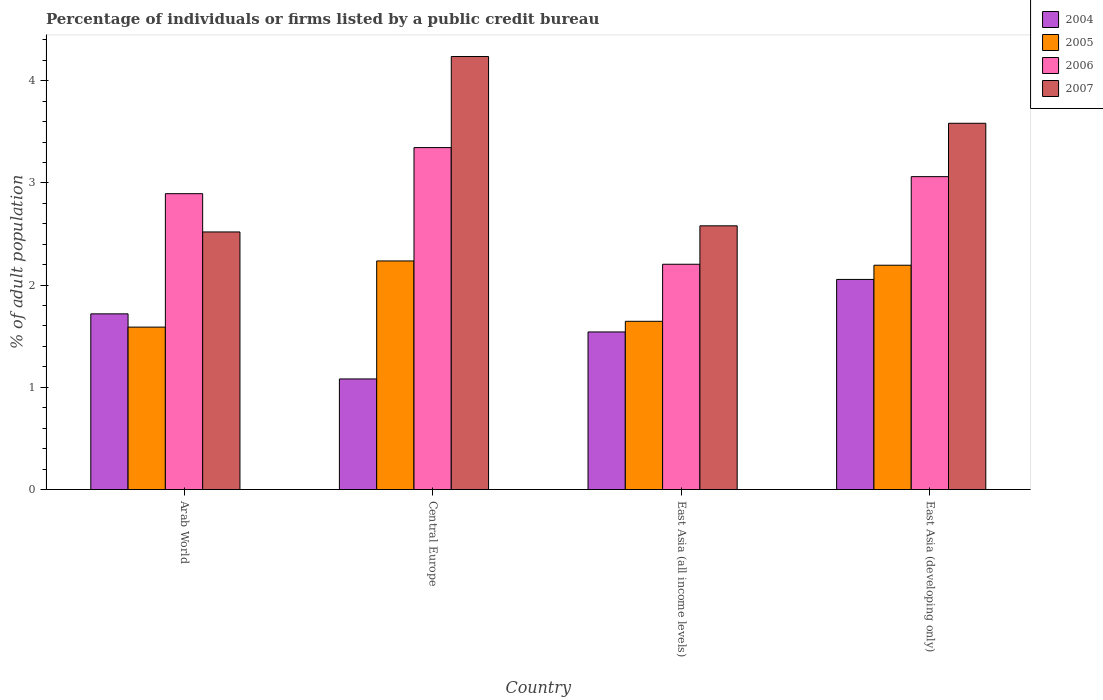How many different coloured bars are there?
Give a very brief answer. 4. Are the number of bars per tick equal to the number of legend labels?
Offer a very short reply. Yes. Are the number of bars on each tick of the X-axis equal?
Your answer should be very brief. Yes. What is the label of the 1st group of bars from the left?
Offer a very short reply. Arab World. In how many cases, is the number of bars for a given country not equal to the number of legend labels?
Make the answer very short. 0. What is the percentage of population listed by a public credit bureau in 2007 in East Asia (developing only)?
Ensure brevity in your answer.  3.58. Across all countries, what is the maximum percentage of population listed by a public credit bureau in 2004?
Your answer should be compact. 2.06. Across all countries, what is the minimum percentage of population listed by a public credit bureau in 2006?
Give a very brief answer. 2.2. In which country was the percentage of population listed by a public credit bureau in 2006 maximum?
Offer a very short reply. Central Europe. In which country was the percentage of population listed by a public credit bureau in 2005 minimum?
Offer a terse response. Arab World. What is the total percentage of population listed by a public credit bureau in 2004 in the graph?
Provide a succinct answer. 6.4. What is the difference between the percentage of population listed by a public credit bureau in 2007 in Arab World and that in East Asia (developing only)?
Your response must be concise. -1.06. What is the difference between the percentage of population listed by a public credit bureau in 2004 in East Asia (developing only) and the percentage of population listed by a public credit bureau in 2006 in Central Europe?
Make the answer very short. -1.29. What is the average percentage of population listed by a public credit bureau in 2006 per country?
Keep it short and to the point. 2.88. What is the difference between the percentage of population listed by a public credit bureau of/in 2006 and percentage of population listed by a public credit bureau of/in 2004 in East Asia (developing only)?
Make the answer very short. 1.01. In how many countries, is the percentage of population listed by a public credit bureau in 2004 greater than 3.6 %?
Your answer should be very brief. 0. What is the ratio of the percentage of population listed by a public credit bureau in 2004 in Central Europe to that in East Asia (all income levels)?
Keep it short and to the point. 0.7. Is the difference between the percentage of population listed by a public credit bureau in 2006 in Central Europe and East Asia (all income levels) greater than the difference between the percentage of population listed by a public credit bureau in 2004 in Central Europe and East Asia (all income levels)?
Keep it short and to the point. Yes. What is the difference between the highest and the second highest percentage of population listed by a public credit bureau in 2004?
Your answer should be very brief. -0.34. What is the difference between the highest and the lowest percentage of population listed by a public credit bureau in 2005?
Offer a terse response. 0.65. In how many countries, is the percentage of population listed by a public credit bureau in 2004 greater than the average percentage of population listed by a public credit bureau in 2004 taken over all countries?
Provide a short and direct response. 2. Is the sum of the percentage of population listed by a public credit bureau in 2005 in Arab World and East Asia (developing only) greater than the maximum percentage of population listed by a public credit bureau in 2007 across all countries?
Keep it short and to the point. No. Is it the case that in every country, the sum of the percentage of population listed by a public credit bureau in 2004 and percentage of population listed by a public credit bureau in 2005 is greater than the sum of percentage of population listed by a public credit bureau in 2007 and percentage of population listed by a public credit bureau in 2006?
Ensure brevity in your answer.  Yes. What does the 1st bar from the left in Central Europe represents?
Keep it short and to the point. 2004. What does the 1st bar from the right in Central Europe represents?
Your response must be concise. 2007. Is it the case that in every country, the sum of the percentage of population listed by a public credit bureau in 2007 and percentage of population listed by a public credit bureau in 2005 is greater than the percentage of population listed by a public credit bureau in 2006?
Give a very brief answer. Yes. How many bars are there?
Make the answer very short. 16. Are all the bars in the graph horizontal?
Ensure brevity in your answer.  No. How many countries are there in the graph?
Provide a short and direct response. 4. What is the difference between two consecutive major ticks on the Y-axis?
Offer a very short reply. 1. Does the graph contain grids?
Provide a short and direct response. No. Where does the legend appear in the graph?
Provide a succinct answer. Top right. What is the title of the graph?
Your response must be concise. Percentage of individuals or firms listed by a public credit bureau. What is the label or title of the X-axis?
Give a very brief answer. Country. What is the label or title of the Y-axis?
Your answer should be compact. % of adult population. What is the % of adult population of 2004 in Arab World?
Provide a succinct answer. 1.72. What is the % of adult population of 2005 in Arab World?
Provide a short and direct response. 1.59. What is the % of adult population of 2006 in Arab World?
Offer a terse response. 2.89. What is the % of adult population of 2007 in Arab World?
Give a very brief answer. 2.52. What is the % of adult population of 2004 in Central Europe?
Your answer should be compact. 1.08. What is the % of adult population in 2005 in Central Europe?
Your answer should be very brief. 2.24. What is the % of adult population of 2006 in Central Europe?
Keep it short and to the point. 3.35. What is the % of adult population of 2007 in Central Europe?
Give a very brief answer. 4.24. What is the % of adult population in 2004 in East Asia (all income levels)?
Offer a terse response. 1.54. What is the % of adult population in 2005 in East Asia (all income levels)?
Offer a very short reply. 1.65. What is the % of adult population in 2006 in East Asia (all income levels)?
Keep it short and to the point. 2.2. What is the % of adult population of 2007 in East Asia (all income levels)?
Make the answer very short. 2.58. What is the % of adult population in 2004 in East Asia (developing only)?
Offer a very short reply. 2.06. What is the % of adult population of 2005 in East Asia (developing only)?
Give a very brief answer. 2.19. What is the % of adult population in 2006 in East Asia (developing only)?
Ensure brevity in your answer.  3.06. What is the % of adult population in 2007 in East Asia (developing only)?
Give a very brief answer. 3.58. Across all countries, what is the maximum % of adult population in 2004?
Offer a very short reply. 2.06. Across all countries, what is the maximum % of adult population in 2005?
Provide a short and direct response. 2.24. Across all countries, what is the maximum % of adult population of 2006?
Offer a terse response. 3.35. Across all countries, what is the maximum % of adult population of 2007?
Offer a terse response. 4.24. Across all countries, what is the minimum % of adult population in 2004?
Give a very brief answer. 1.08. Across all countries, what is the minimum % of adult population in 2005?
Make the answer very short. 1.59. Across all countries, what is the minimum % of adult population in 2006?
Ensure brevity in your answer.  2.2. Across all countries, what is the minimum % of adult population of 2007?
Your response must be concise. 2.52. What is the total % of adult population of 2004 in the graph?
Keep it short and to the point. 6.4. What is the total % of adult population of 2005 in the graph?
Provide a succinct answer. 7.67. What is the total % of adult population of 2006 in the graph?
Your response must be concise. 11.51. What is the total % of adult population of 2007 in the graph?
Your response must be concise. 12.92. What is the difference between the % of adult population in 2004 in Arab World and that in Central Europe?
Your response must be concise. 0.64. What is the difference between the % of adult population of 2005 in Arab World and that in Central Europe?
Provide a short and direct response. -0.65. What is the difference between the % of adult population of 2006 in Arab World and that in Central Europe?
Ensure brevity in your answer.  -0.45. What is the difference between the % of adult population in 2007 in Arab World and that in Central Europe?
Make the answer very short. -1.72. What is the difference between the % of adult population in 2004 in Arab World and that in East Asia (all income levels)?
Provide a short and direct response. 0.18. What is the difference between the % of adult population of 2005 in Arab World and that in East Asia (all income levels)?
Your answer should be compact. -0.06. What is the difference between the % of adult population in 2006 in Arab World and that in East Asia (all income levels)?
Offer a terse response. 0.69. What is the difference between the % of adult population of 2007 in Arab World and that in East Asia (all income levels)?
Keep it short and to the point. -0.06. What is the difference between the % of adult population in 2004 in Arab World and that in East Asia (developing only)?
Provide a succinct answer. -0.34. What is the difference between the % of adult population of 2005 in Arab World and that in East Asia (developing only)?
Make the answer very short. -0.61. What is the difference between the % of adult population of 2007 in Arab World and that in East Asia (developing only)?
Your response must be concise. -1.06. What is the difference between the % of adult population of 2004 in Central Europe and that in East Asia (all income levels)?
Offer a terse response. -0.46. What is the difference between the % of adult population in 2005 in Central Europe and that in East Asia (all income levels)?
Keep it short and to the point. 0.59. What is the difference between the % of adult population of 2006 in Central Europe and that in East Asia (all income levels)?
Your answer should be very brief. 1.14. What is the difference between the % of adult population in 2007 in Central Europe and that in East Asia (all income levels)?
Offer a terse response. 1.66. What is the difference between the % of adult population of 2004 in Central Europe and that in East Asia (developing only)?
Provide a succinct answer. -0.97. What is the difference between the % of adult population of 2005 in Central Europe and that in East Asia (developing only)?
Offer a terse response. 0.04. What is the difference between the % of adult population in 2006 in Central Europe and that in East Asia (developing only)?
Make the answer very short. 0.28. What is the difference between the % of adult population of 2007 in Central Europe and that in East Asia (developing only)?
Offer a very short reply. 0.65. What is the difference between the % of adult population of 2004 in East Asia (all income levels) and that in East Asia (developing only)?
Offer a terse response. -0.51. What is the difference between the % of adult population of 2005 in East Asia (all income levels) and that in East Asia (developing only)?
Provide a short and direct response. -0.55. What is the difference between the % of adult population in 2006 in East Asia (all income levels) and that in East Asia (developing only)?
Provide a succinct answer. -0.86. What is the difference between the % of adult population in 2007 in East Asia (all income levels) and that in East Asia (developing only)?
Provide a succinct answer. -1. What is the difference between the % of adult population of 2004 in Arab World and the % of adult population of 2005 in Central Europe?
Ensure brevity in your answer.  -0.52. What is the difference between the % of adult population of 2004 in Arab World and the % of adult population of 2006 in Central Europe?
Provide a succinct answer. -1.63. What is the difference between the % of adult population of 2004 in Arab World and the % of adult population of 2007 in Central Europe?
Provide a short and direct response. -2.52. What is the difference between the % of adult population of 2005 in Arab World and the % of adult population of 2006 in Central Europe?
Your answer should be very brief. -1.76. What is the difference between the % of adult population of 2005 in Arab World and the % of adult population of 2007 in Central Europe?
Provide a short and direct response. -2.65. What is the difference between the % of adult population of 2006 in Arab World and the % of adult population of 2007 in Central Europe?
Offer a terse response. -1.34. What is the difference between the % of adult population in 2004 in Arab World and the % of adult population in 2005 in East Asia (all income levels)?
Make the answer very short. 0.07. What is the difference between the % of adult population in 2004 in Arab World and the % of adult population in 2006 in East Asia (all income levels)?
Your answer should be very brief. -0.49. What is the difference between the % of adult population of 2004 in Arab World and the % of adult population of 2007 in East Asia (all income levels)?
Provide a succinct answer. -0.86. What is the difference between the % of adult population in 2005 in Arab World and the % of adult population in 2006 in East Asia (all income levels)?
Provide a succinct answer. -0.62. What is the difference between the % of adult population in 2005 in Arab World and the % of adult population in 2007 in East Asia (all income levels)?
Give a very brief answer. -0.99. What is the difference between the % of adult population of 2006 in Arab World and the % of adult population of 2007 in East Asia (all income levels)?
Ensure brevity in your answer.  0.31. What is the difference between the % of adult population in 2004 in Arab World and the % of adult population in 2005 in East Asia (developing only)?
Your answer should be very brief. -0.48. What is the difference between the % of adult population in 2004 in Arab World and the % of adult population in 2006 in East Asia (developing only)?
Keep it short and to the point. -1.34. What is the difference between the % of adult population in 2004 in Arab World and the % of adult population in 2007 in East Asia (developing only)?
Keep it short and to the point. -1.86. What is the difference between the % of adult population of 2005 in Arab World and the % of adult population of 2006 in East Asia (developing only)?
Give a very brief answer. -1.47. What is the difference between the % of adult population of 2005 in Arab World and the % of adult population of 2007 in East Asia (developing only)?
Offer a terse response. -1.99. What is the difference between the % of adult population in 2006 in Arab World and the % of adult population in 2007 in East Asia (developing only)?
Ensure brevity in your answer.  -0.69. What is the difference between the % of adult population in 2004 in Central Europe and the % of adult population in 2005 in East Asia (all income levels)?
Offer a terse response. -0.56. What is the difference between the % of adult population in 2004 in Central Europe and the % of adult population in 2006 in East Asia (all income levels)?
Provide a succinct answer. -1.12. What is the difference between the % of adult population of 2004 in Central Europe and the % of adult population of 2007 in East Asia (all income levels)?
Your response must be concise. -1.5. What is the difference between the % of adult population of 2005 in Central Europe and the % of adult population of 2006 in East Asia (all income levels)?
Provide a succinct answer. 0.03. What is the difference between the % of adult population in 2005 in Central Europe and the % of adult population in 2007 in East Asia (all income levels)?
Provide a succinct answer. -0.34. What is the difference between the % of adult population of 2006 in Central Europe and the % of adult population of 2007 in East Asia (all income levels)?
Your answer should be very brief. 0.77. What is the difference between the % of adult population of 2004 in Central Europe and the % of adult population of 2005 in East Asia (developing only)?
Make the answer very short. -1.11. What is the difference between the % of adult population of 2004 in Central Europe and the % of adult population of 2006 in East Asia (developing only)?
Offer a terse response. -1.98. What is the difference between the % of adult population of 2004 in Central Europe and the % of adult population of 2007 in East Asia (developing only)?
Your answer should be very brief. -2.5. What is the difference between the % of adult population of 2005 in Central Europe and the % of adult population of 2006 in East Asia (developing only)?
Your answer should be very brief. -0.82. What is the difference between the % of adult population in 2005 in Central Europe and the % of adult population in 2007 in East Asia (developing only)?
Keep it short and to the point. -1.35. What is the difference between the % of adult population of 2006 in Central Europe and the % of adult population of 2007 in East Asia (developing only)?
Provide a short and direct response. -0.24. What is the difference between the % of adult population in 2004 in East Asia (all income levels) and the % of adult population in 2005 in East Asia (developing only)?
Keep it short and to the point. -0.65. What is the difference between the % of adult population of 2004 in East Asia (all income levels) and the % of adult population of 2006 in East Asia (developing only)?
Ensure brevity in your answer.  -1.52. What is the difference between the % of adult population in 2004 in East Asia (all income levels) and the % of adult population in 2007 in East Asia (developing only)?
Ensure brevity in your answer.  -2.04. What is the difference between the % of adult population of 2005 in East Asia (all income levels) and the % of adult population of 2006 in East Asia (developing only)?
Offer a terse response. -1.42. What is the difference between the % of adult population in 2005 in East Asia (all income levels) and the % of adult population in 2007 in East Asia (developing only)?
Ensure brevity in your answer.  -1.94. What is the difference between the % of adult population of 2006 in East Asia (all income levels) and the % of adult population of 2007 in East Asia (developing only)?
Your answer should be compact. -1.38. What is the average % of adult population in 2004 per country?
Your answer should be compact. 1.6. What is the average % of adult population in 2005 per country?
Provide a short and direct response. 1.92. What is the average % of adult population in 2006 per country?
Your answer should be compact. 2.88. What is the average % of adult population of 2007 per country?
Your answer should be compact. 3.23. What is the difference between the % of adult population of 2004 and % of adult population of 2005 in Arab World?
Your response must be concise. 0.13. What is the difference between the % of adult population in 2004 and % of adult population in 2006 in Arab World?
Give a very brief answer. -1.18. What is the difference between the % of adult population of 2004 and % of adult population of 2007 in Arab World?
Offer a very short reply. -0.8. What is the difference between the % of adult population in 2005 and % of adult population in 2006 in Arab World?
Your answer should be very brief. -1.31. What is the difference between the % of adult population in 2005 and % of adult population in 2007 in Arab World?
Provide a succinct answer. -0.93. What is the difference between the % of adult population of 2006 and % of adult population of 2007 in Arab World?
Give a very brief answer. 0.37. What is the difference between the % of adult population of 2004 and % of adult population of 2005 in Central Europe?
Offer a terse response. -1.15. What is the difference between the % of adult population in 2004 and % of adult population in 2006 in Central Europe?
Offer a very short reply. -2.26. What is the difference between the % of adult population in 2004 and % of adult population in 2007 in Central Europe?
Your answer should be compact. -3.15. What is the difference between the % of adult population in 2005 and % of adult population in 2006 in Central Europe?
Offer a very short reply. -1.11. What is the difference between the % of adult population of 2006 and % of adult population of 2007 in Central Europe?
Make the answer very short. -0.89. What is the difference between the % of adult population in 2004 and % of adult population in 2005 in East Asia (all income levels)?
Make the answer very short. -0.1. What is the difference between the % of adult population in 2004 and % of adult population in 2006 in East Asia (all income levels)?
Offer a terse response. -0.66. What is the difference between the % of adult population in 2004 and % of adult population in 2007 in East Asia (all income levels)?
Provide a succinct answer. -1.04. What is the difference between the % of adult population of 2005 and % of adult population of 2006 in East Asia (all income levels)?
Your answer should be compact. -0.56. What is the difference between the % of adult population of 2005 and % of adult population of 2007 in East Asia (all income levels)?
Provide a short and direct response. -0.93. What is the difference between the % of adult population in 2006 and % of adult population in 2007 in East Asia (all income levels)?
Your response must be concise. -0.38. What is the difference between the % of adult population in 2004 and % of adult population in 2005 in East Asia (developing only)?
Give a very brief answer. -0.14. What is the difference between the % of adult population in 2004 and % of adult population in 2006 in East Asia (developing only)?
Offer a terse response. -1.01. What is the difference between the % of adult population in 2004 and % of adult population in 2007 in East Asia (developing only)?
Your answer should be very brief. -1.53. What is the difference between the % of adult population of 2005 and % of adult population of 2006 in East Asia (developing only)?
Offer a terse response. -0.87. What is the difference between the % of adult population in 2005 and % of adult population in 2007 in East Asia (developing only)?
Your answer should be compact. -1.39. What is the difference between the % of adult population of 2006 and % of adult population of 2007 in East Asia (developing only)?
Your answer should be compact. -0.52. What is the ratio of the % of adult population in 2004 in Arab World to that in Central Europe?
Offer a terse response. 1.59. What is the ratio of the % of adult population of 2005 in Arab World to that in Central Europe?
Your answer should be compact. 0.71. What is the ratio of the % of adult population in 2006 in Arab World to that in Central Europe?
Make the answer very short. 0.87. What is the ratio of the % of adult population of 2007 in Arab World to that in Central Europe?
Provide a short and direct response. 0.59. What is the ratio of the % of adult population of 2004 in Arab World to that in East Asia (all income levels)?
Offer a very short reply. 1.11. What is the ratio of the % of adult population in 2005 in Arab World to that in East Asia (all income levels)?
Provide a succinct answer. 0.97. What is the ratio of the % of adult population in 2006 in Arab World to that in East Asia (all income levels)?
Make the answer very short. 1.31. What is the ratio of the % of adult population in 2007 in Arab World to that in East Asia (all income levels)?
Offer a terse response. 0.98. What is the ratio of the % of adult population of 2004 in Arab World to that in East Asia (developing only)?
Your answer should be very brief. 0.84. What is the ratio of the % of adult population in 2005 in Arab World to that in East Asia (developing only)?
Keep it short and to the point. 0.72. What is the ratio of the % of adult population in 2006 in Arab World to that in East Asia (developing only)?
Your response must be concise. 0.95. What is the ratio of the % of adult population of 2007 in Arab World to that in East Asia (developing only)?
Your answer should be very brief. 0.7. What is the ratio of the % of adult population of 2004 in Central Europe to that in East Asia (all income levels)?
Ensure brevity in your answer.  0.7. What is the ratio of the % of adult population of 2005 in Central Europe to that in East Asia (all income levels)?
Give a very brief answer. 1.36. What is the ratio of the % of adult population of 2006 in Central Europe to that in East Asia (all income levels)?
Your response must be concise. 1.52. What is the ratio of the % of adult population of 2007 in Central Europe to that in East Asia (all income levels)?
Ensure brevity in your answer.  1.64. What is the ratio of the % of adult population in 2004 in Central Europe to that in East Asia (developing only)?
Give a very brief answer. 0.53. What is the ratio of the % of adult population in 2005 in Central Europe to that in East Asia (developing only)?
Give a very brief answer. 1.02. What is the ratio of the % of adult population of 2006 in Central Europe to that in East Asia (developing only)?
Offer a terse response. 1.09. What is the ratio of the % of adult population in 2007 in Central Europe to that in East Asia (developing only)?
Provide a succinct answer. 1.18. What is the ratio of the % of adult population in 2004 in East Asia (all income levels) to that in East Asia (developing only)?
Offer a terse response. 0.75. What is the ratio of the % of adult population of 2005 in East Asia (all income levels) to that in East Asia (developing only)?
Your answer should be compact. 0.75. What is the ratio of the % of adult population of 2006 in East Asia (all income levels) to that in East Asia (developing only)?
Offer a very short reply. 0.72. What is the ratio of the % of adult population of 2007 in East Asia (all income levels) to that in East Asia (developing only)?
Offer a terse response. 0.72. What is the difference between the highest and the second highest % of adult population of 2004?
Make the answer very short. 0.34. What is the difference between the highest and the second highest % of adult population of 2005?
Offer a terse response. 0.04. What is the difference between the highest and the second highest % of adult population in 2006?
Provide a short and direct response. 0.28. What is the difference between the highest and the second highest % of adult population in 2007?
Your response must be concise. 0.65. What is the difference between the highest and the lowest % of adult population of 2004?
Make the answer very short. 0.97. What is the difference between the highest and the lowest % of adult population in 2005?
Keep it short and to the point. 0.65. What is the difference between the highest and the lowest % of adult population of 2006?
Give a very brief answer. 1.14. What is the difference between the highest and the lowest % of adult population of 2007?
Your answer should be compact. 1.72. 